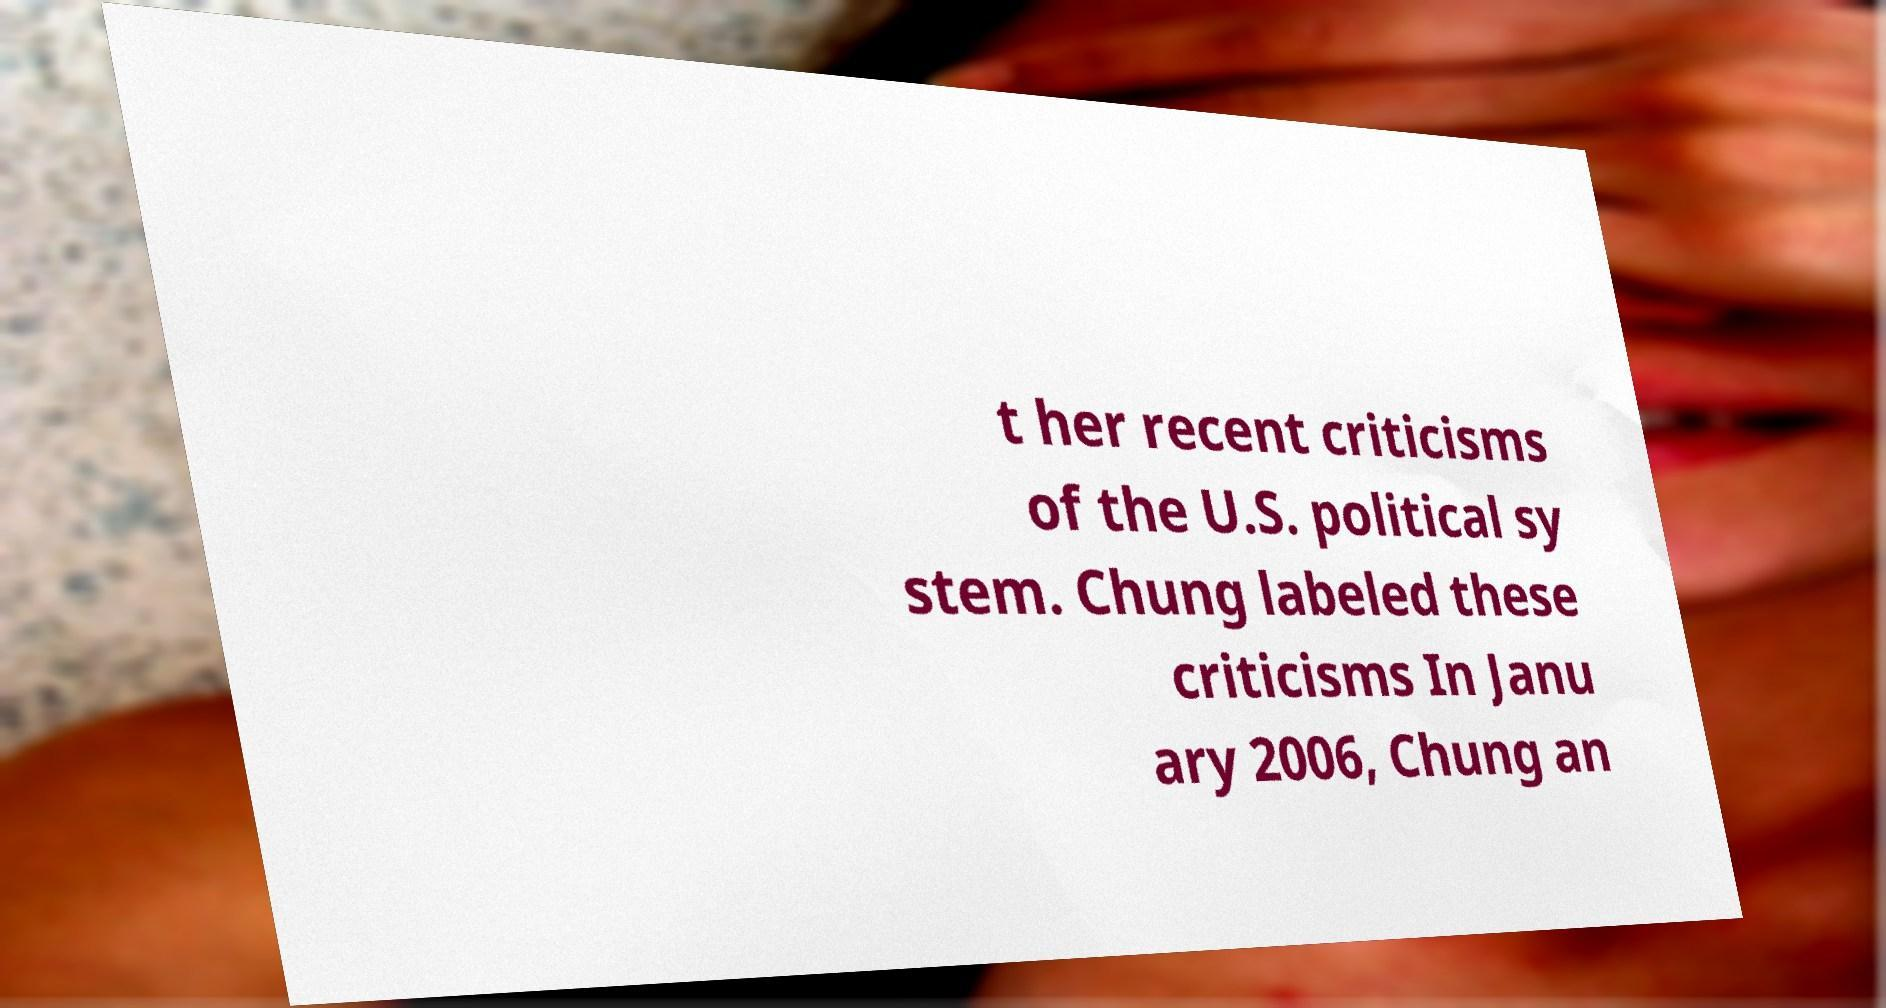Could you extract and type out the text from this image? t her recent criticisms of the U.S. political sy stem. Chung labeled these criticisms In Janu ary 2006, Chung an 